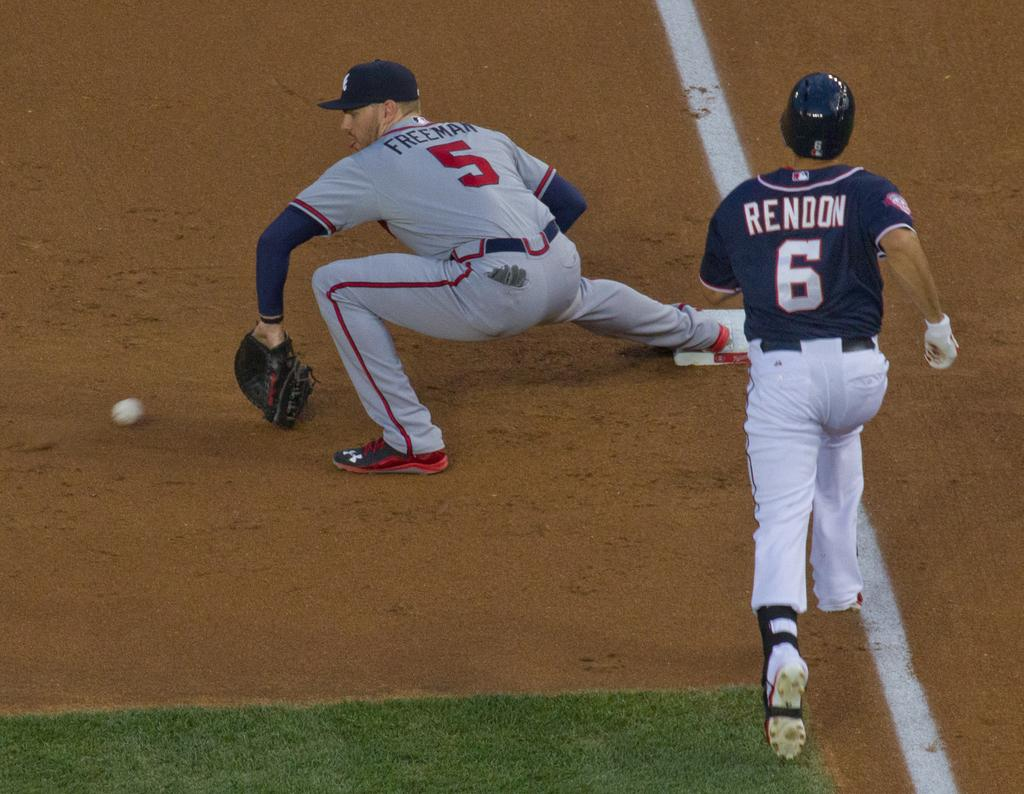<image>
Describe the image concisely. A player named Rendon is wearing jersey number 6 and running toward first base. 